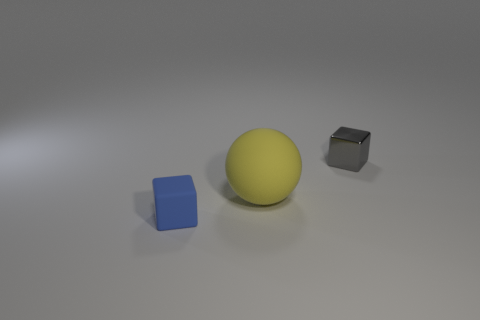Subtract all balls. How many objects are left? 2 Add 2 large yellow shiny spheres. How many objects exist? 5 Subtract 1 balls. How many balls are left? 0 Subtract all gray matte cubes. Subtract all rubber spheres. How many objects are left? 2 Add 1 blue blocks. How many blue blocks are left? 2 Add 3 small shiny blocks. How many small shiny blocks exist? 4 Subtract 0 red spheres. How many objects are left? 3 Subtract all gray balls. Subtract all gray blocks. How many balls are left? 1 